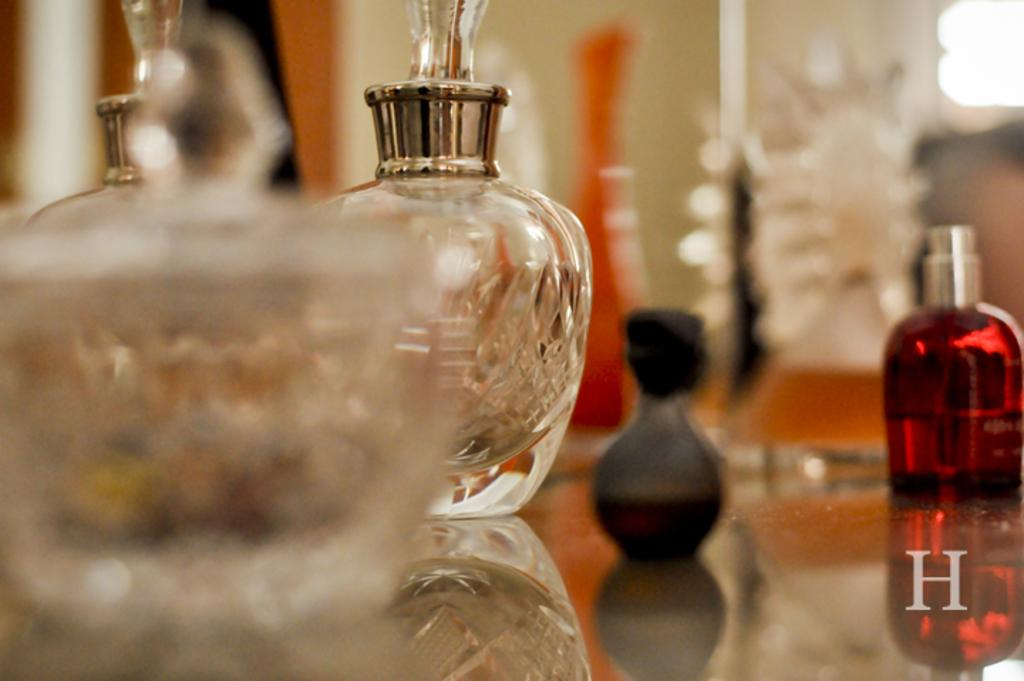What type of containers are visible in the image? There are glass bottles in the image. Can you describe the quality of the image? The image is blurry. Is there any additional information or branding present in the image? Yes, there is a watermark in the image. How many hours of sleep do the bottles require in the image? The bottles do not require sleep, as they are inanimate objects. 